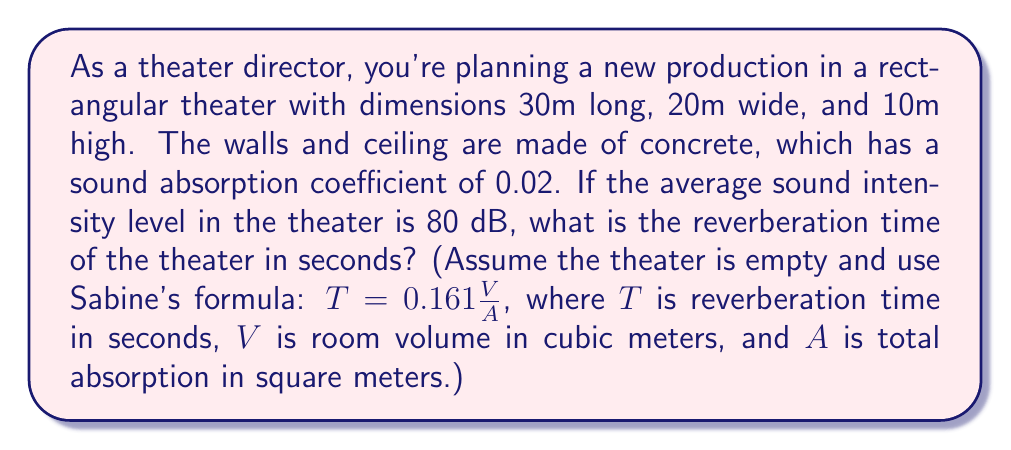What is the answer to this math problem? To solve this problem, we'll follow these steps:

1. Calculate the volume of the theater:
   $$V = 30m \times 20m \times 10m = 6000m^3$$

2. Calculate the surface area of the theater:
   $$S_{floor} = S_{ceiling} = 30m \times 20m = 600m^2$$
   $$S_{long walls} = 2 \times (30m \times 10m) = 600m^2$$
   $$S_{short walls} = 2 \times (20m \times 10m) = 400m^2$$
   $$S_{total} = 600 + 600 + 600 + 400 = 2200m^2$$

3. Calculate the total absorption:
   $$A = S_{total} \times \text{absorption coefficient}$$
   $$A = 2200m^2 \times 0.02 = 44m^2$$

4. Apply Sabine's formula:
   $$T = 0.161 \frac{V}{A}$$
   $$T = 0.161 \frac{6000m^3}{44m^2}$$
   $$T = 21.95 \text{ seconds}$$

Therefore, the reverberation time of the theater is approximately 21.95 seconds.
Answer: 21.95 seconds 